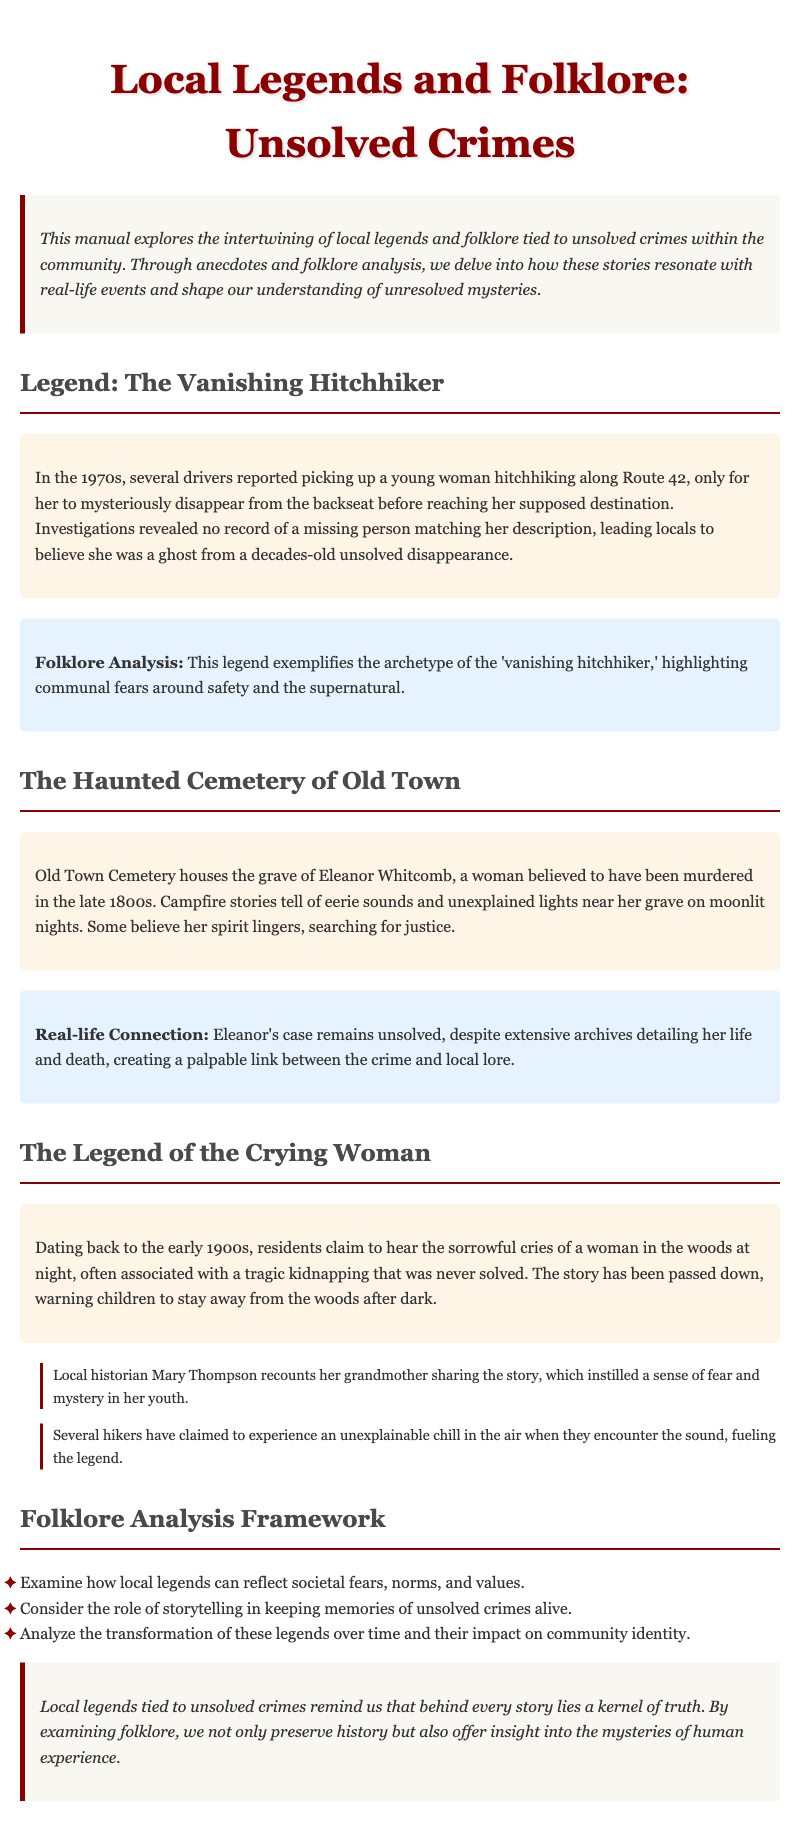What legend involves a young woman hitchhiking? The document describes the "Vanishing Hitchhiker" legend where several drivers reported picking up a young woman who mysteriously disappeared.
Answer: Vanishing Hitchhiker In what decade did the Vanishing Hitchhiker legend begin? The document states that the Vanishing Hitchhiker legend started in the 1970s.
Answer: 1970s Who is believed to be murdered in the Old Town Cemetery? The legend mentions Eleanor Whitcomb as the woman believed to have been murdered.
Answer: Eleanor Whitcomb What is the main theme of the Crying Woman legend? The Crying Woman legend is associated with a tragic kidnapping that was never solved and instills fear in children to avoid the woods after dark.
Answer: Tragic kidnapping What type of framework is outlined in the document for folklore analysis? The document lists a folklore analysis framework that examines societal fears, storytelling, and transformation of legends over time.
Answer: Folklore Analysis Framework What does the introduction of the document emphasize? The introduction emphasizes the intertwining of local legends and real-life unsolved crimes in the community, shaping understanding of mysteries.
Answer: Local legends and unsolved crimes How does the document categorize the analysis of folklore? The document categorizes the analysis under a "Folklore Analysis Framework" with specific areas to examine societal fears, storytelling, and community identity.
Answer: Folklore Analysis Framework What is the tone of the conclusion in the document? The conclusion conveys a reflective tone about the connection between local legends and unsolved mysteries, emphasizing the preservation of history.
Answer: Reflective 